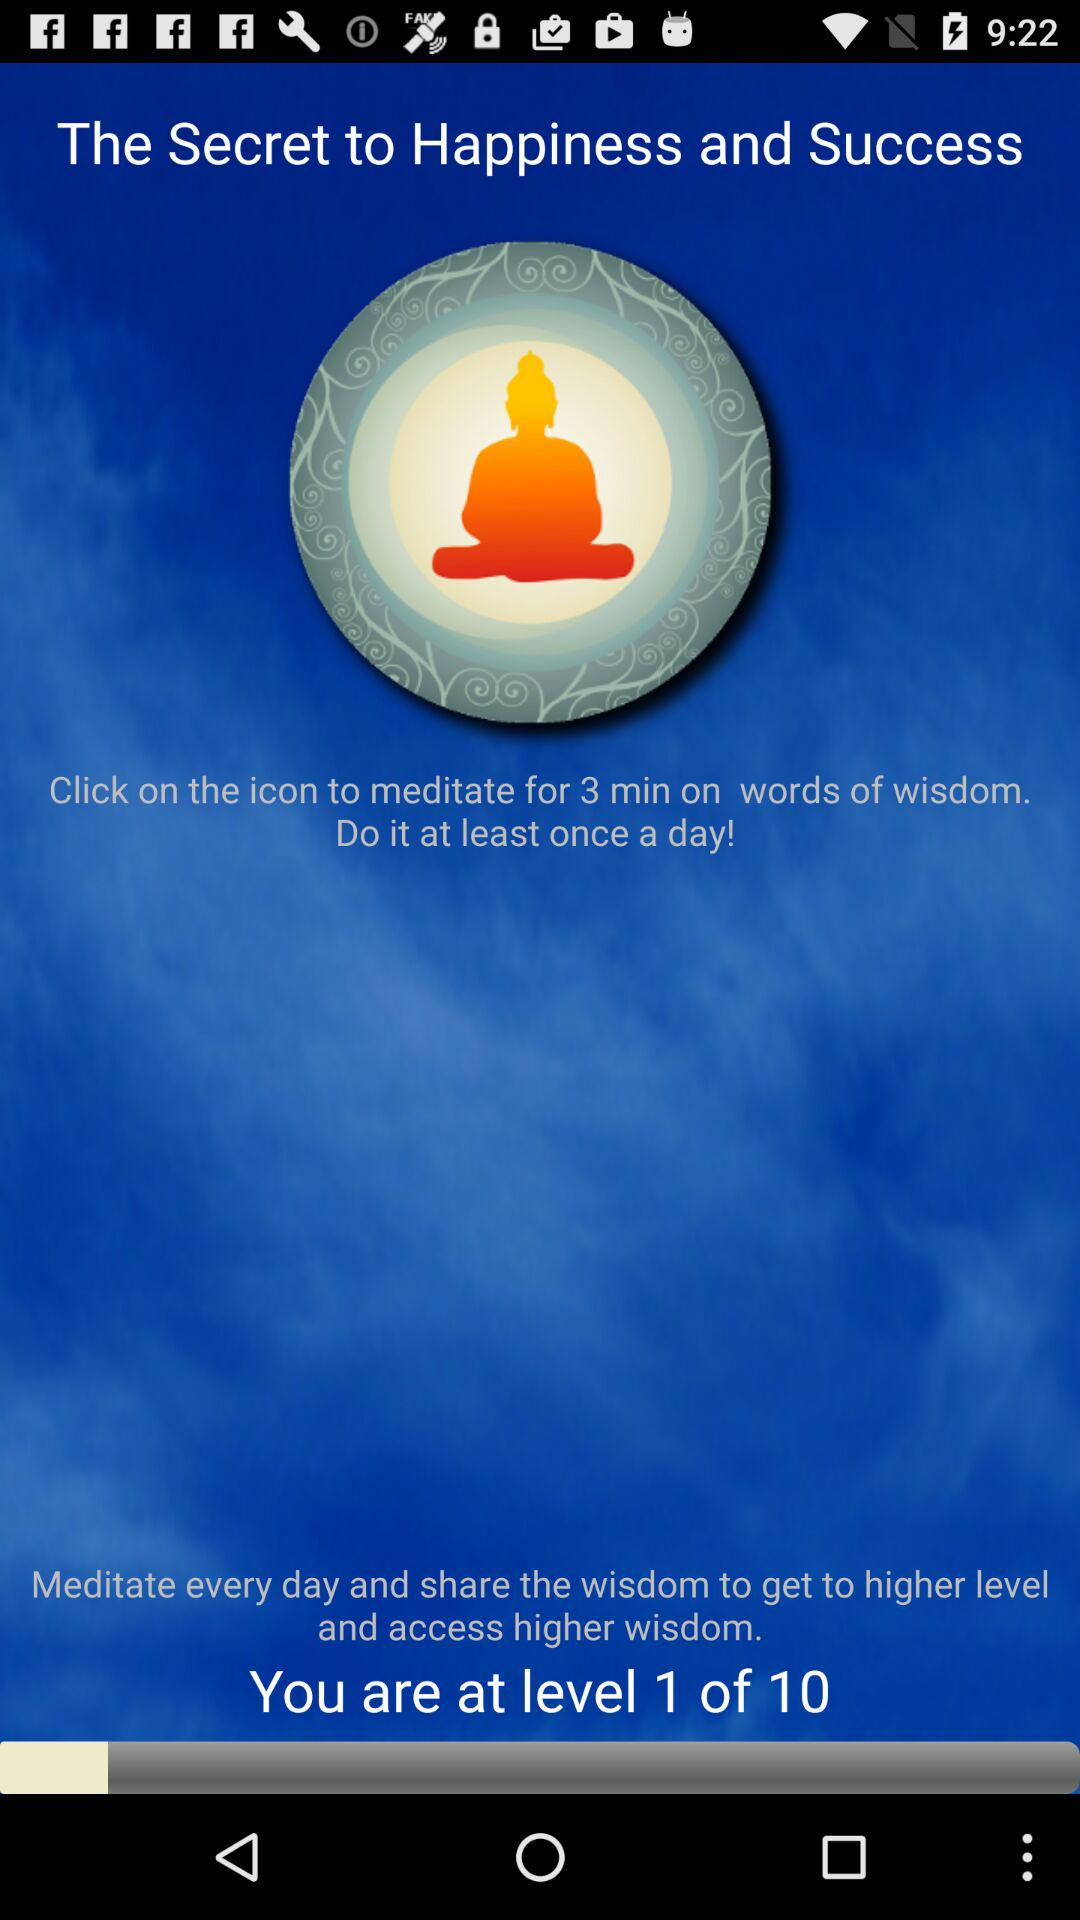Which level am I at? You are at level 1. 